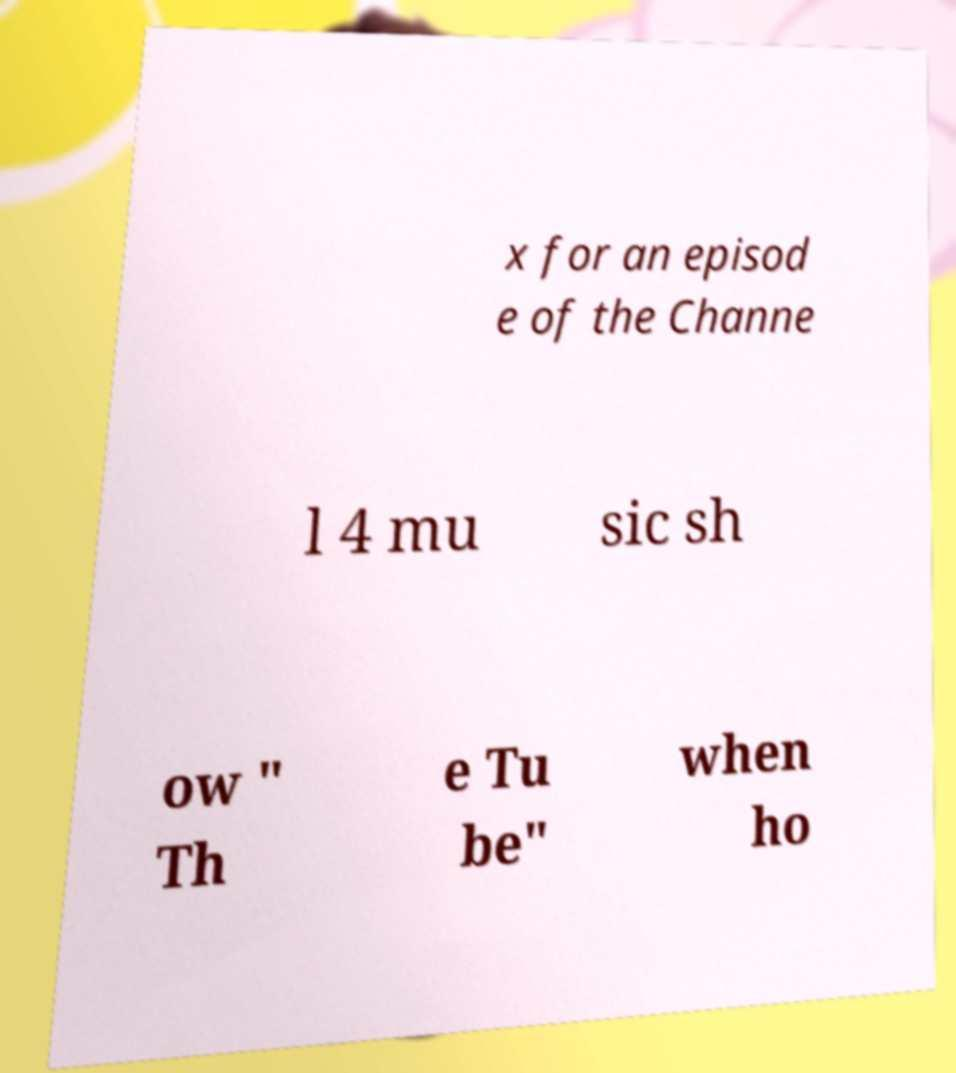What messages or text are displayed in this image? I need them in a readable, typed format. x for an episod e of the Channe l 4 mu sic sh ow " Th e Tu be" when ho 